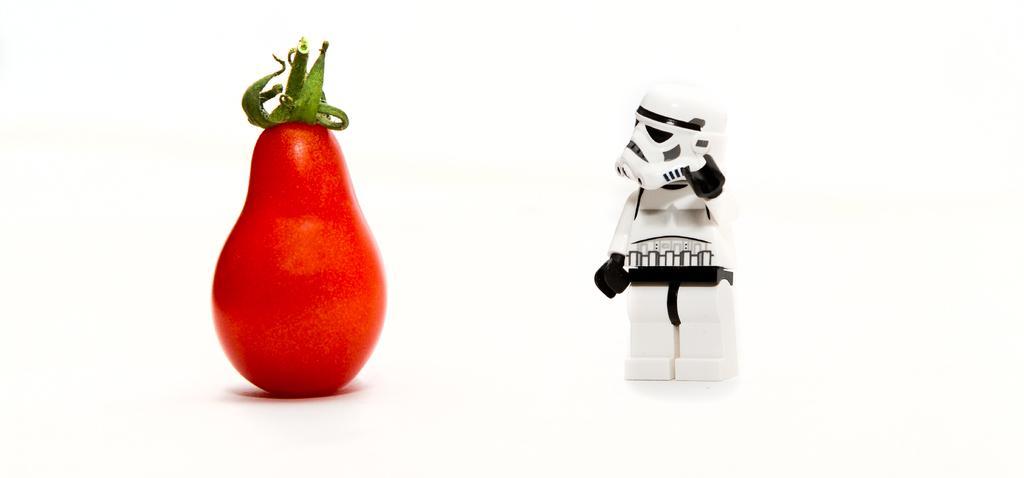What type of vegetable is in the image? The specific type of vegetable is not mentioned, but there is a vegetable in the image. What other object can be seen in the image? There is a toy in the image. Where are the vegetable and the toy located? Both the vegetable and the toy are on a platform. What type of straw is being used to support the toy in the image? There is no straw present in the image; the toy and vegetable are on a platform. What type of bone can be seen in the image? There is no bone present in the image. 